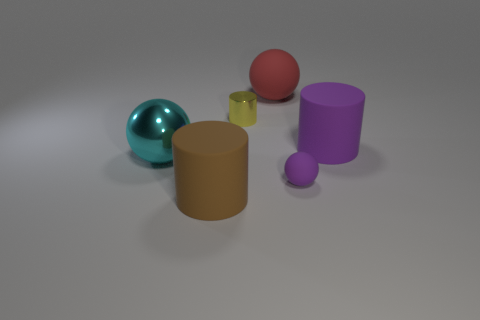There is a metal thing that is the same shape as the tiny purple matte thing; what color is it?
Your answer should be very brief. Cyan. What number of big red matte objects are the same shape as the large purple object?
Provide a short and direct response. 0. How many objects are either yellow metallic things or big rubber objects to the right of the brown rubber thing?
Make the answer very short. 3. Does the metal sphere have the same color as the rubber thing to the left of the small yellow shiny cylinder?
Provide a short and direct response. No. There is a sphere that is both in front of the shiny cylinder and on the right side of the brown cylinder; how big is it?
Ensure brevity in your answer.  Small. Are there any balls left of the red ball?
Provide a succinct answer. Yes. There is a big rubber thing that is in front of the purple ball; are there any large metallic things to the right of it?
Give a very brief answer. No. Are there an equal number of small purple objects left of the large brown matte object and metallic cylinders left of the small yellow cylinder?
Provide a succinct answer. Yes. What color is the tiny thing that is made of the same material as the large red thing?
Provide a succinct answer. Purple. Is there a cylinder that has the same material as the big red object?
Give a very brief answer. Yes. 